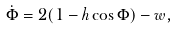<formula> <loc_0><loc_0><loc_500><loc_500>\dot { \Phi } = 2 ( 1 - h \cos \Phi ) - w ,</formula> 